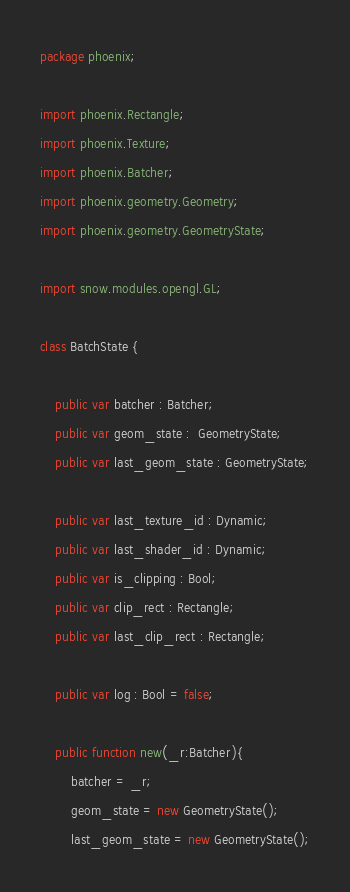Convert code to text. <code><loc_0><loc_0><loc_500><loc_500><_Haxe_>package phoenix;

import phoenix.Rectangle;
import phoenix.Texture;
import phoenix.Batcher;
import phoenix.geometry.Geometry;
import phoenix.geometry.GeometryState;

import snow.modules.opengl.GL;

class BatchState {

    public var batcher : Batcher;
    public var geom_state :  GeometryState;
    public var last_geom_state : GeometryState;

    public var last_texture_id : Dynamic;
    public var last_shader_id : Dynamic;
    public var is_clipping : Bool;
    public var clip_rect : Rectangle;
    public var last_clip_rect : Rectangle;

    public var log : Bool = false;

    public function new(_r:Batcher){
        batcher = _r;
        geom_state = new GeometryState();
        last_geom_state = new GeometryState();</code> 